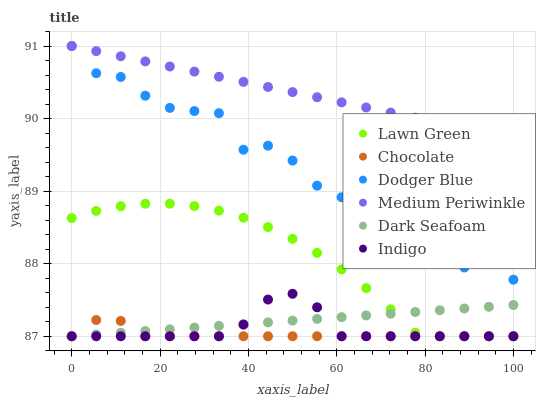Does Chocolate have the minimum area under the curve?
Answer yes or no. Yes. Does Medium Periwinkle have the maximum area under the curve?
Answer yes or no. Yes. Does Indigo have the minimum area under the curve?
Answer yes or no. No. Does Indigo have the maximum area under the curve?
Answer yes or no. No. Is Dark Seafoam the smoothest?
Answer yes or no. Yes. Is Dodger Blue the roughest?
Answer yes or no. Yes. Is Indigo the smoothest?
Answer yes or no. No. Is Indigo the roughest?
Answer yes or no. No. Does Lawn Green have the lowest value?
Answer yes or no. Yes. Does Medium Periwinkle have the lowest value?
Answer yes or no. No. Does Dodger Blue have the highest value?
Answer yes or no. Yes. Does Indigo have the highest value?
Answer yes or no. No. Is Chocolate less than Medium Periwinkle?
Answer yes or no. Yes. Is Dodger Blue greater than Lawn Green?
Answer yes or no. Yes. Does Chocolate intersect Lawn Green?
Answer yes or no. Yes. Is Chocolate less than Lawn Green?
Answer yes or no. No. Is Chocolate greater than Lawn Green?
Answer yes or no. No. Does Chocolate intersect Medium Periwinkle?
Answer yes or no. No. 